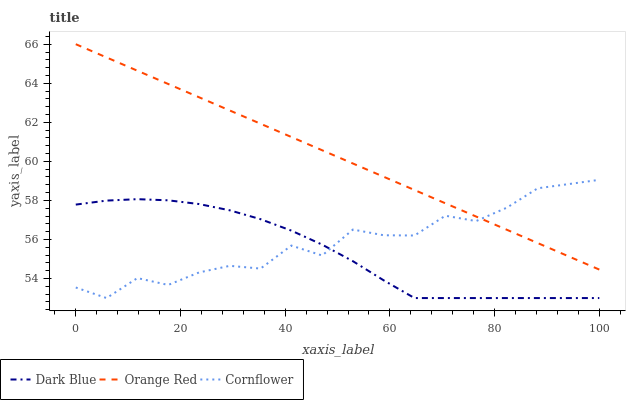Does Dark Blue have the minimum area under the curve?
Answer yes or no. Yes. Does Orange Red have the maximum area under the curve?
Answer yes or no. Yes. Does Cornflower have the minimum area under the curve?
Answer yes or no. No. Does Cornflower have the maximum area under the curve?
Answer yes or no. No. Is Orange Red the smoothest?
Answer yes or no. Yes. Is Cornflower the roughest?
Answer yes or no. Yes. Is Cornflower the smoothest?
Answer yes or no. No. Is Orange Red the roughest?
Answer yes or no. No. Does Dark Blue have the lowest value?
Answer yes or no. Yes. Does Orange Red have the lowest value?
Answer yes or no. No. Does Orange Red have the highest value?
Answer yes or no. Yes. Does Cornflower have the highest value?
Answer yes or no. No. Is Dark Blue less than Orange Red?
Answer yes or no. Yes. Is Orange Red greater than Dark Blue?
Answer yes or no. Yes. Does Cornflower intersect Dark Blue?
Answer yes or no. Yes. Is Cornflower less than Dark Blue?
Answer yes or no. No. Is Cornflower greater than Dark Blue?
Answer yes or no. No. Does Dark Blue intersect Orange Red?
Answer yes or no. No. 